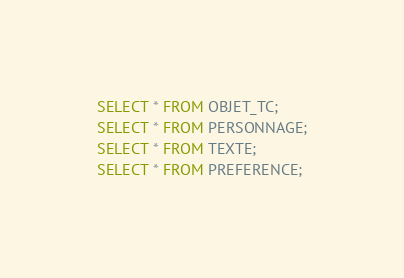Convert code to text. <code><loc_0><loc_0><loc_500><loc_500><_SQL_>SELECT * FROM OBJET_TC;
SELECT * FROM PERSONNAGE;
SELECT * FROM TEXTE;
SELECT * FROM PREFERENCE;
</code> 